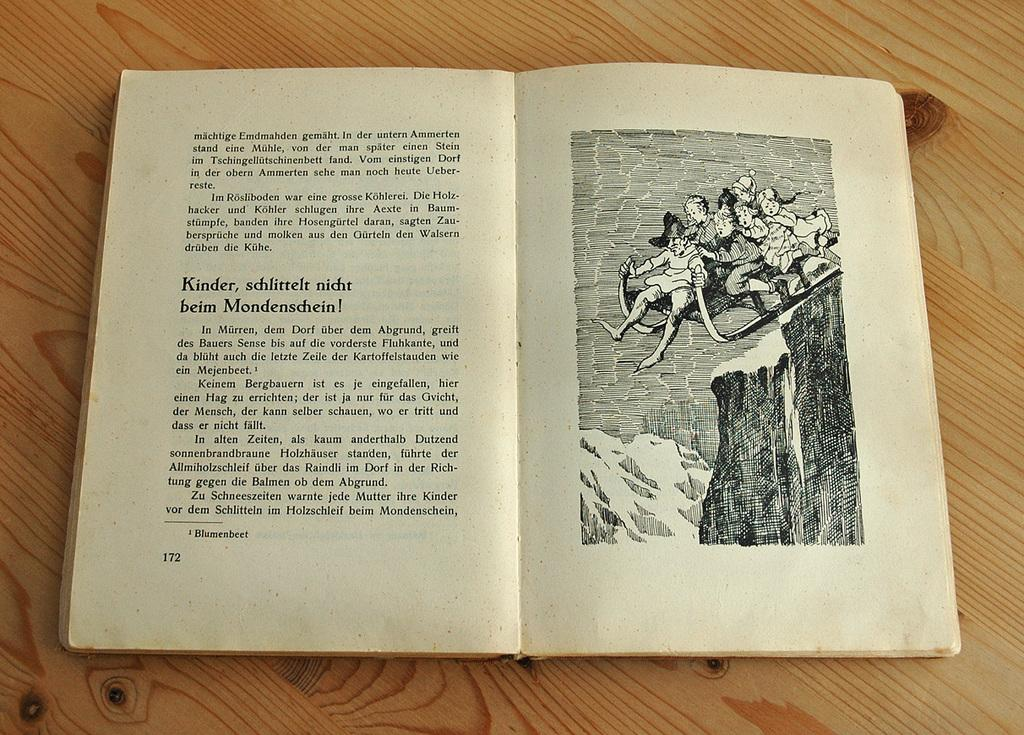<image>
Create a compact narrative representing the image presented. A book is open to page 172 with an image on one side and text on the other. 